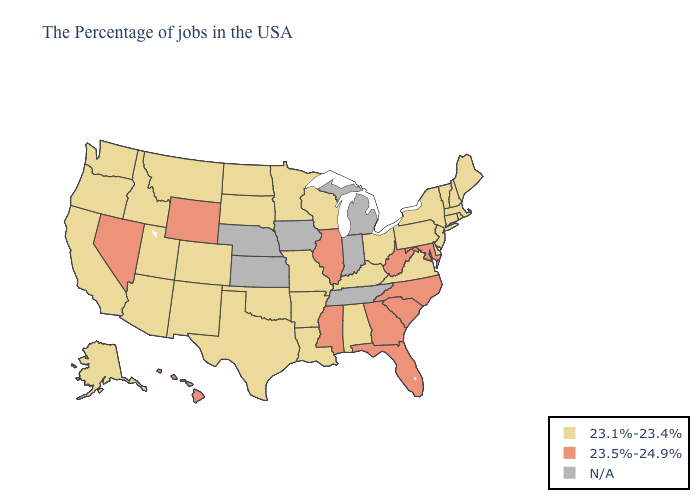Name the states that have a value in the range N/A?
Quick response, please. Michigan, Indiana, Tennessee, Iowa, Kansas, Nebraska. Name the states that have a value in the range 23.1%-23.4%?
Short answer required. Maine, Massachusetts, Rhode Island, New Hampshire, Vermont, Connecticut, New York, New Jersey, Delaware, Pennsylvania, Virginia, Ohio, Kentucky, Alabama, Wisconsin, Louisiana, Missouri, Arkansas, Minnesota, Oklahoma, Texas, South Dakota, North Dakota, Colorado, New Mexico, Utah, Montana, Arizona, Idaho, California, Washington, Oregon, Alaska. Name the states that have a value in the range 23.5%-24.9%?
Give a very brief answer. Maryland, North Carolina, South Carolina, West Virginia, Florida, Georgia, Illinois, Mississippi, Wyoming, Nevada, Hawaii. What is the lowest value in states that border Alabama?
Write a very short answer. 23.5%-24.9%. Name the states that have a value in the range 23.1%-23.4%?
Concise answer only. Maine, Massachusetts, Rhode Island, New Hampshire, Vermont, Connecticut, New York, New Jersey, Delaware, Pennsylvania, Virginia, Ohio, Kentucky, Alabama, Wisconsin, Louisiana, Missouri, Arkansas, Minnesota, Oklahoma, Texas, South Dakota, North Dakota, Colorado, New Mexico, Utah, Montana, Arizona, Idaho, California, Washington, Oregon, Alaska. Which states have the highest value in the USA?
Keep it brief. Maryland, North Carolina, South Carolina, West Virginia, Florida, Georgia, Illinois, Mississippi, Wyoming, Nevada, Hawaii. What is the value of Kansas?
Be succinct. N/A. Among the states that border Wisconsin , does Minnesota have the highest value?
Answer briefly. No. What is the value of Wisconsin?
Keep it brief. 23.1%-23.4%. Does Utah have the highest value in the USA?
Quick response, please. No. Among the states that border Idaho , which have the highest value?
Quick response, please. Wyoming, Nevada. Name the states that have a value in the range N/A?
Short answer required. Michigan, Indiana, Tennessee, Iowa, Kansas, Nebraska. What is the lowest value in the South?
Write a very short answer. 23.1%-23.4%. 